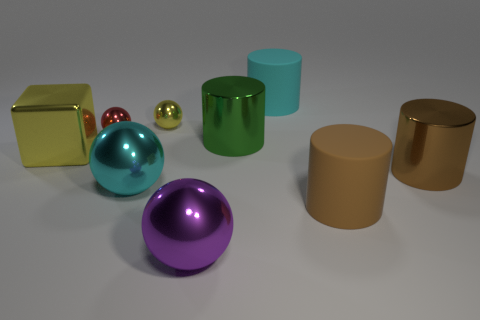What color is the other metal sphere that is the same size as the purple metal sphere?
Your response must be concise. Cyan. Are there any other large objects of the same shape as the red metallic object?
Your response must be concise. Yes. What is the shape of the red metallic object?
Provide a succinct answer. Sphere. Is the number of big cyan spheres that are right of the large brown metal object greater than the number of cylinders that are in front of the green metallic cylinder?
Make the answer very short. No. How many other things are the same size as the cyan shiny object?
Your answer should be compact. 6. The big object that is both behind the metallic cube and to the left of the cyan cylinder is made of what material?
Offer a very short reply. Metal. There is a big green thing that is the same shape as the big brown metallic object; what is it made of?
Your answer should be very brief. Metal. There is a purple thing that is in front of the cyan rubber cylinder on the left side of the big brown metallic object; how many brown rubber objects are in front of it?
Give a very brief answer. 0. What number of big cylinders are behind the small yellow metal sphere and in front of the green cylinder?
Provide a short and direct response. 0. There is a rubber cylinder that is in front of the big yellow block; is it the same size as the yellow metallic object to the left of the large cyan ball?
Keep it short and to the point. Yes. 